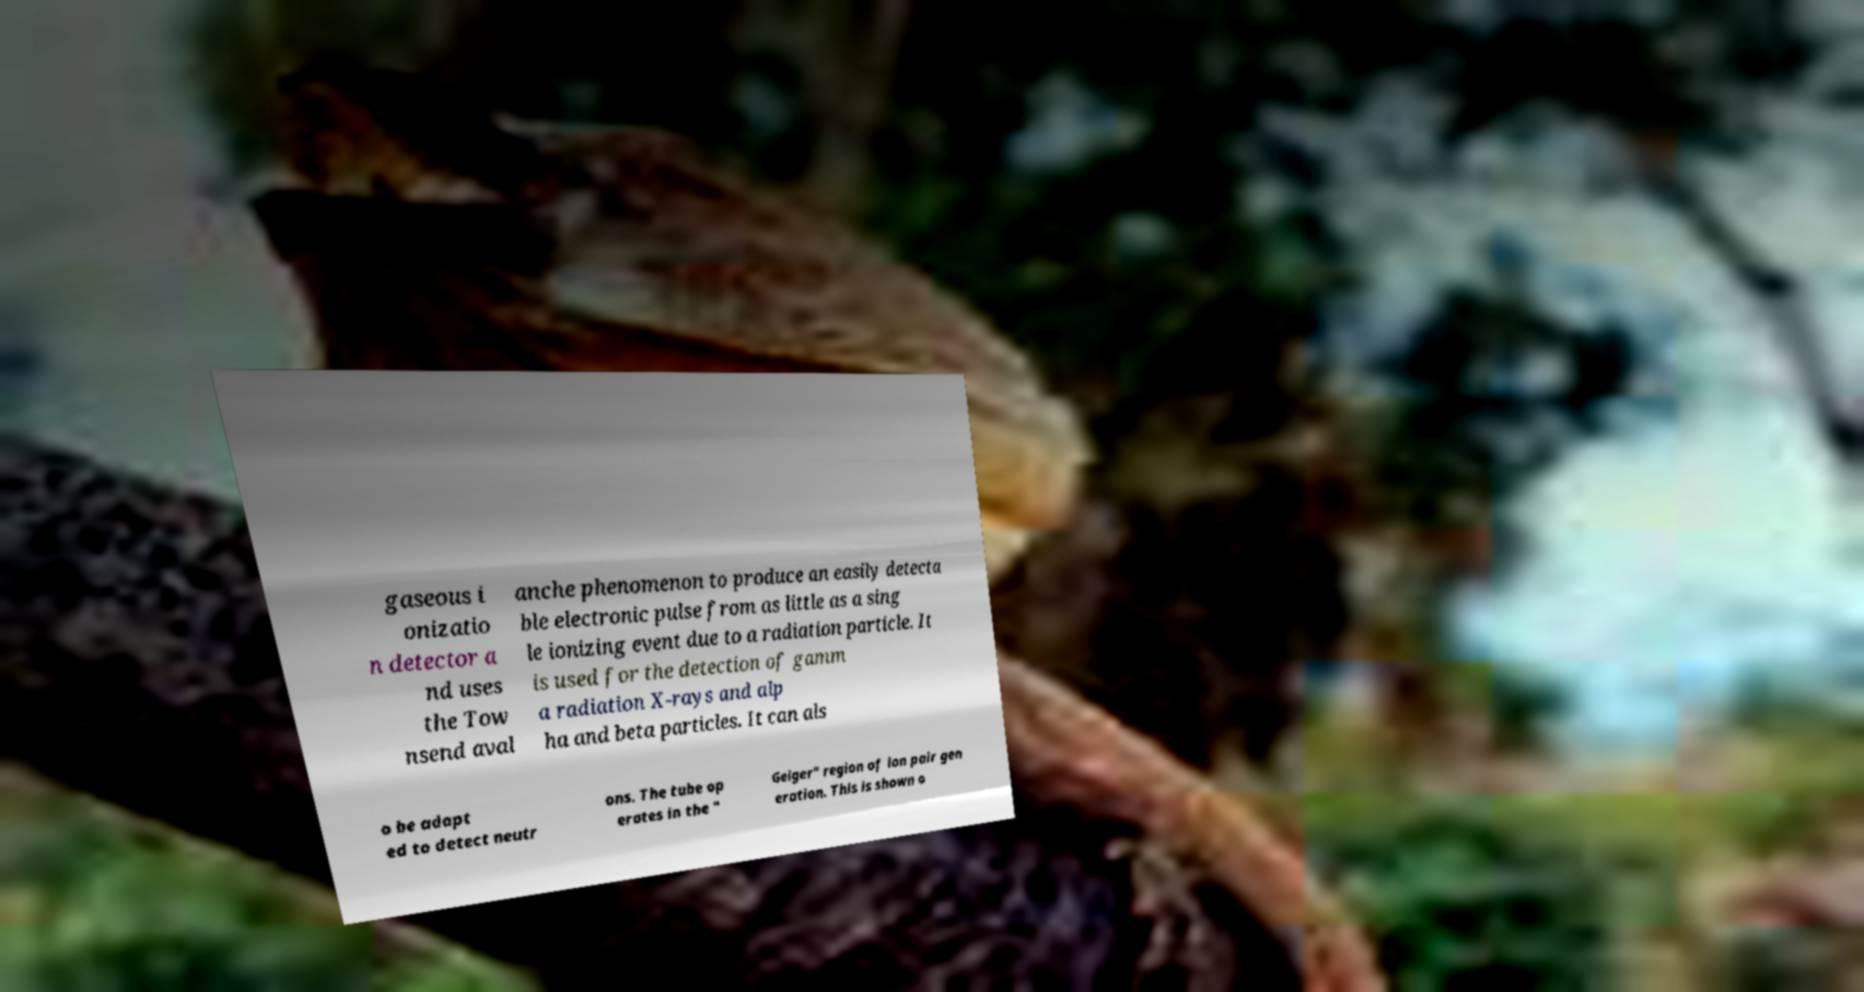There's text embedded in this image that I need extracted. Can you transcribe it verbatim? gaseous i onizatio n detector a nd uses the Tow nsend aval anche phenomenon to produce an easily detecta ble electronic pulse from as little as a sing le ionizing event due to a radiation particle. It is used for the detection of gamm a radiation X-rays and alp ha and beta particles. It can als o be adapt ed to detect neutr ons. The tube op erates in the " Geiger" region of ion pair gen eration. This is shown o 